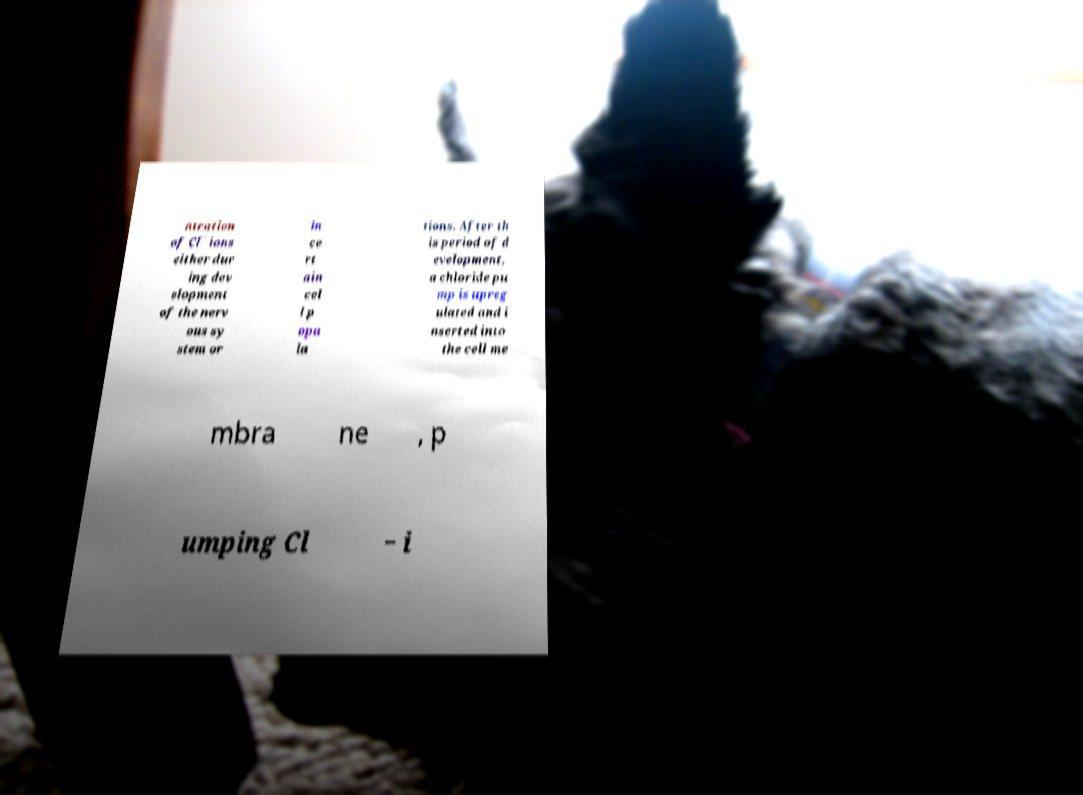What messages or text are displayed in this image? I need them in a readable, typed format. ntration of Cl¯ ions either dur ing dev elopment of the nerv ous sy stem or in ce rt ain cel l p opu la tions. After th is period of d evelopment, a chloride pu mp is upreg ulated and i nserted into the cell me mbra ne , p umping Cl − i 